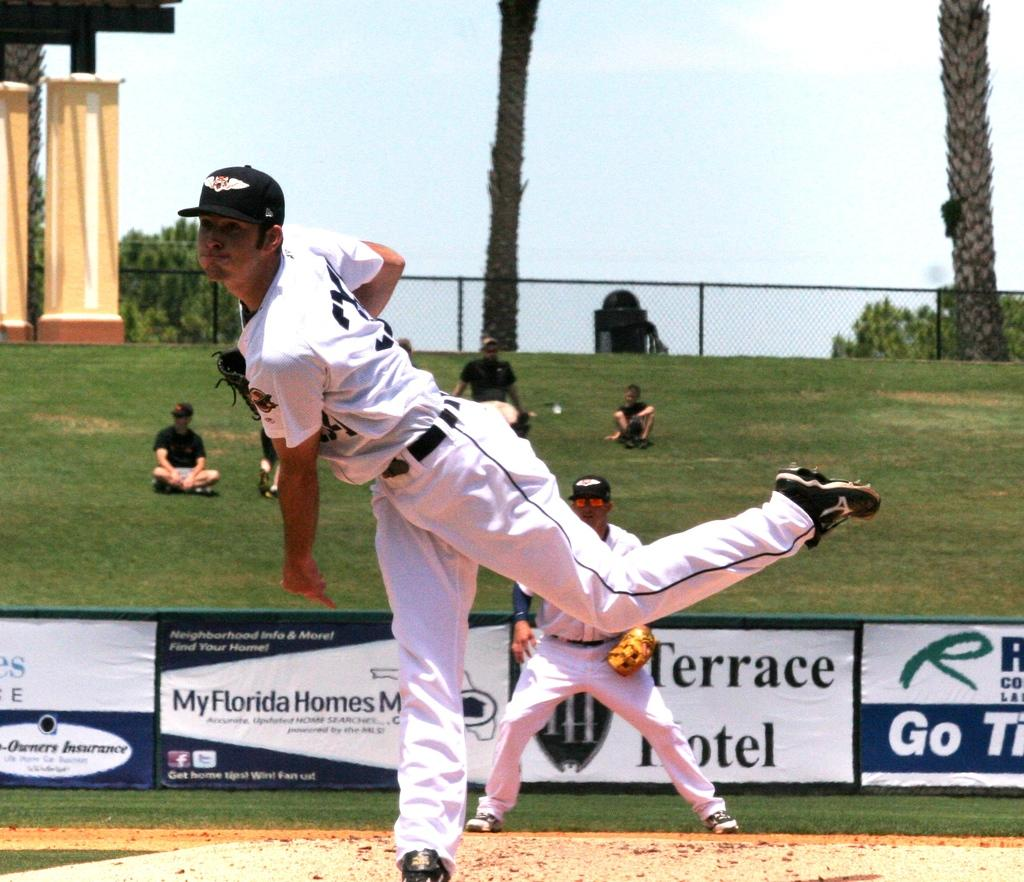<image>
Provide a brief description of the given image. A baseball game is underway at a stadium with advertisements for Terrace Hotel. 